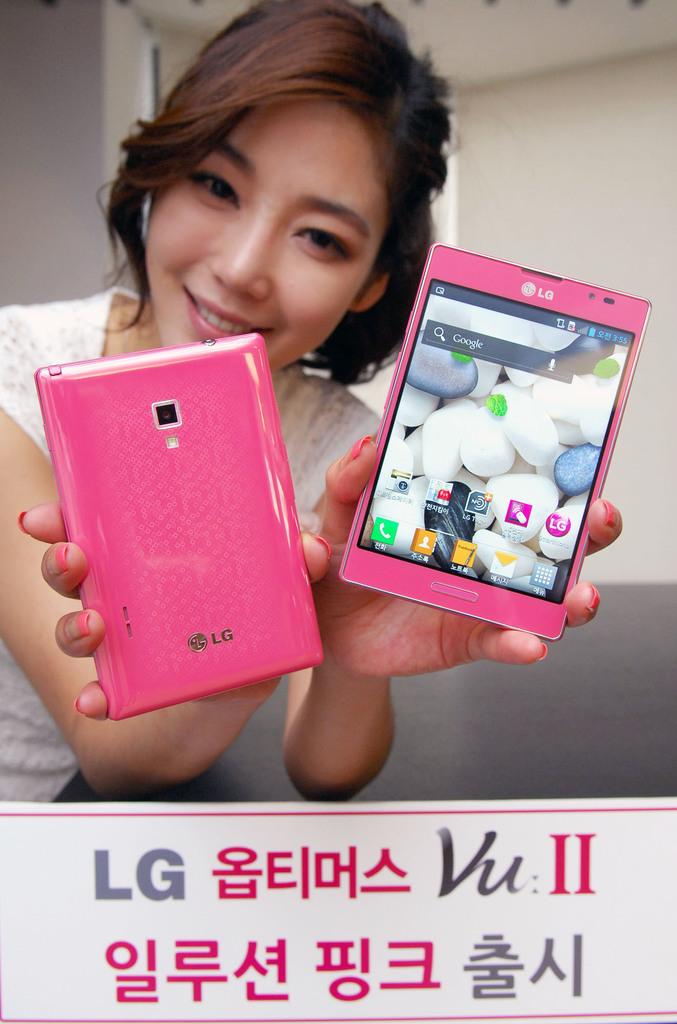Who makes the cell phone?
Your answer should be very brief. Lg. 